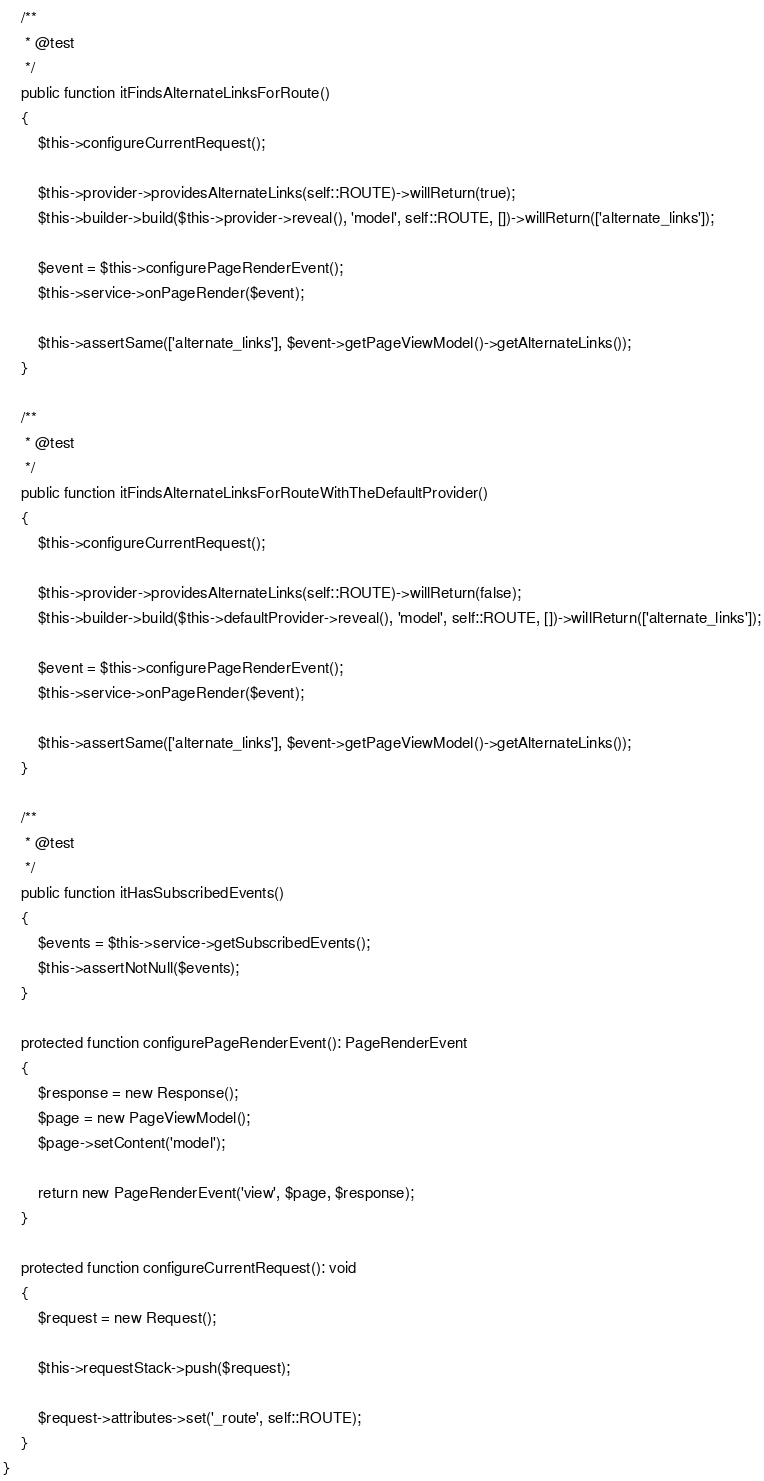Convert code to text. <code><loc_0><loc_0><loc_500><loc_500><_PHP_>
    /**
     * @test
     */
    public function itFindsAlternateLinksForRoute()
    {
        $this->configureCurrentRequest();

        $this->provider->providesAlternateLinks(self::ROUTE)->willReturn(true);
        $this->builder->build($this->provider->reveal(), 'model', self::ROUTE, [])->willReturn(['alternate_links']);

        $event = $this->configurePageRenderEvent();
        $this->service->onPageRender($event);

        $this->assertSame(['alternate_links'], $event->getPageViewModel()->getAlternateLinks());
    }

    /**
     * @test
     */
    public function itFindsAlternateLinksForRouteWithTheDefaultProvider()
    {
        $this->configureCurrentRequest();

        $this->provider->providesAlternateLinks(self::ROUTE)->willReturn(false);
        $this->builder->build($this->defaultProvider->reveal(), 'model', self::ROUTE, [])->willReturn(['alternate_links']);

        $event = $this->configurePageRenderEvent();
        $this->service->onPageRender($event);

        $this->assertSame(['alternate_links'], $event->getPageViewModel()->getAlternateLinks());
    }

    /**
     * @test
     */
    public function itHasSubscribedEvents()
    {
        $events = $this->service->getSubscribedEvents();
        $this->assertNotNull($events);
    }

    protected function configurePageRenderEvent(): PageRenderEvent
    {
        $response = new Response();
        $page = new PageViewModel();
        $page->setContent('model');

        return new PageRenderEvent('view', $page, $response);
    }

    protected function configureCurrentRequest(): void
    {
        $request = new Request();

        $this->requestStack->push($request);

        $request->attributes->set('_route', self::ROUTE);
    }
}
</code> 